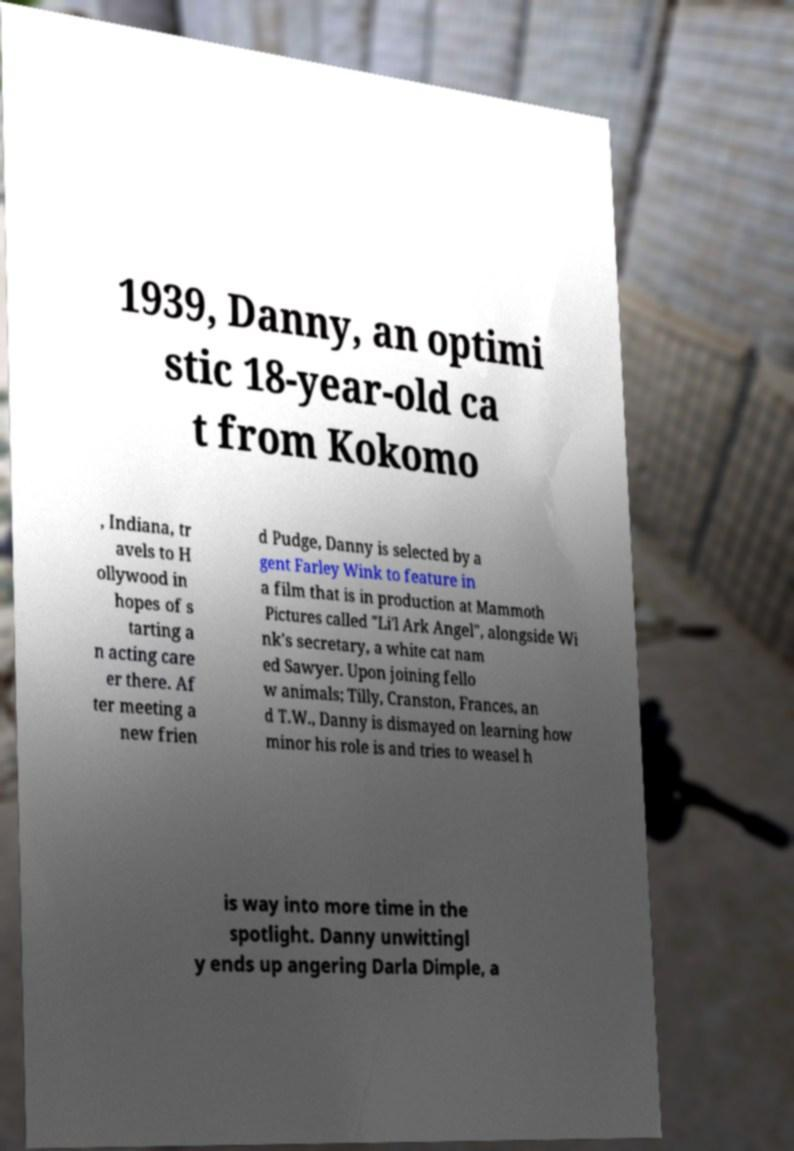What messages or text are displayed in this image? I need them in a readable, typed format. 1939, Danny, an optimi stic 18-year-old ca t from Kokomo , Indiana, tr avels to H ollywood in hopes of s tarting a n acting care er there. Af ter meeting a new frien d Pudge, Danny is selected by a gent Farley Wink to feature in a film that is in production at Mammoth Pictures called "Li'l Ark Angel", alongside Wi nk's secretary, a white cat nam ed Sawyer. Upon joining fello w animals; Tilly, Cranston, Frances, an d T.W., Danny is dismayed on learning how minor his role is and tries to weasel h is way into more time in the spotlight. Danny unwittingl y ends up angering Darla Dimple, a 